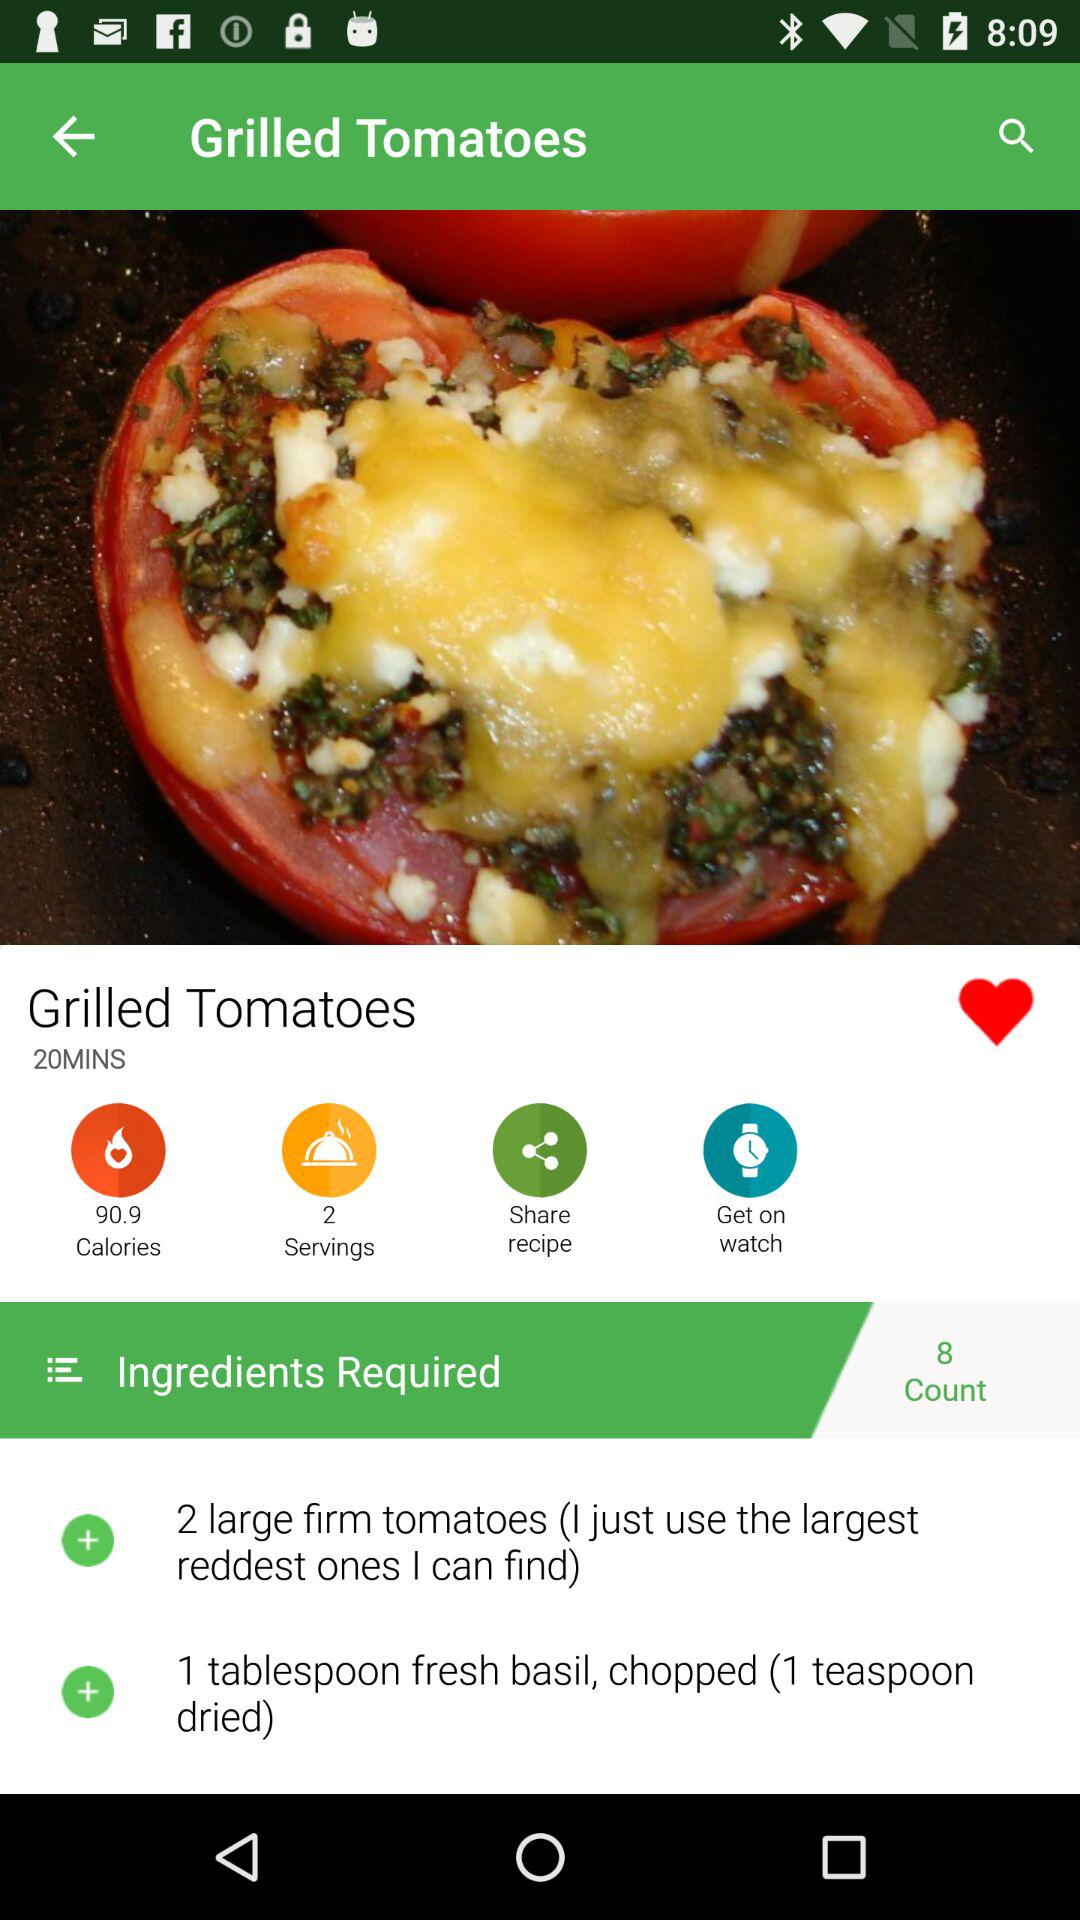What is the cooking time? The cooking time is 20 minutes. 